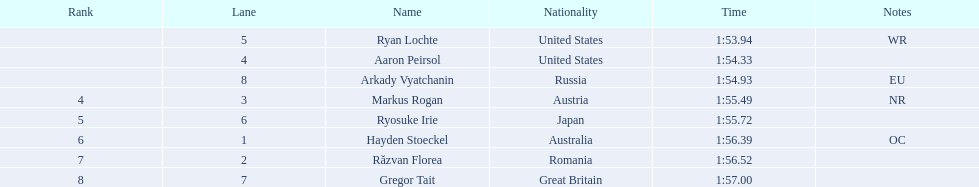Who took part in the occasion? Ryan Lochte, Aaron Peirsol, Arkady Vyatchanin, Markus Rogan, Ryosuke Irie, Hayden Stoeckel, Răzvan Florea, Gregor Tait. What was the completion time of every sportsperson? 1:53.94, 1:54.33, 1:54.93, 1:55.49, 1:55.72, 1:56.39, 1:56.52, 1:57.00. And specifically for ryosuke irie? 1:55.72. 